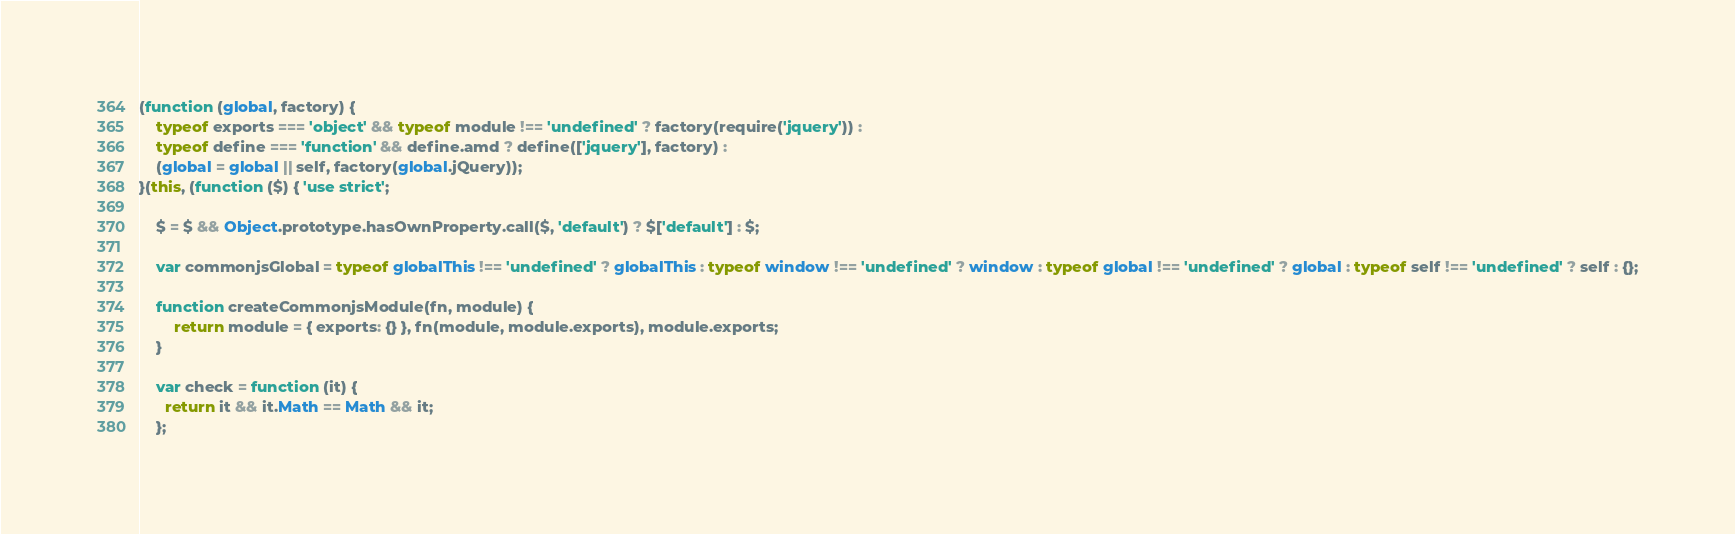<code> <loc_0><loc_0><loc_500><loc_500><_JavaScript_>(function (global, factory) {
	typeof exports === 'object' && typeof module !== 'undefined' ? factory(require('jquery')) :
	typeof define === 'function' && define.amd ? define(['jquery'], factory) :
	(global = global || self, factory(global.jQuery));
}(this, (function ($) { 'use strict';

	$ = $ && Object.prototype.hasOwnProperty.call($, 'default') ? $['default'] : $;

	var commonjsGlobal = typeof globalThis !== 'undefined' ? globalThis : typeof window !== 'undefined' ? window : typeof global !== 'undefined' ? global : typeof self !== 'undefined' ? self : {};

	function createCommonjsModule(fn, module) {
		return module = { exports: {} }, fn(module, module.exports), module.exports;
	}

	var check = function (it) {
	  return it && it.Math == Math && it;
	};
</code> 